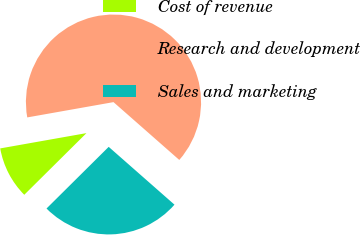<chart> <loc_0><loc_0><loc_500><loc_500><pie_chart><fcel>Cost of revenue<fcel>Research and development<fcel>Sales and marketing<nl><fcel>9.64%<fcel>64.27%<fcel>26.09%<nl></chart> 